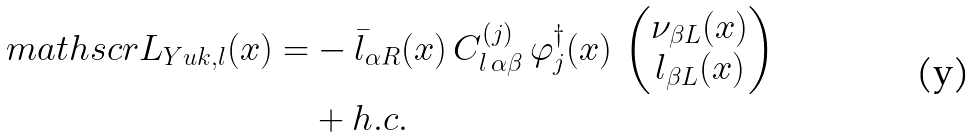Convert formula to latex. <formula><loc_0><loc_0><loc_500><loc_500>\ m a t h s c r { L } _ { Y u k , l } ( x ) = & - \bar { l } _ { \alpha R } ( x ) \, C ^ { ( j ) } _ { l \, \alpha \beta } \, \varphi _ { j } ^ { \dagger } ( x ) \, \begin{pmatrix} \nu _ { \beta L } ( x ) \\ l _ { \beta L } ( x ) \end{pmatrix} \\ & + h . c .</formula> 